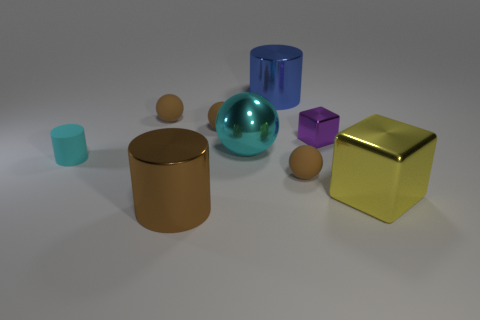There is a small object that is the same color as the metal sphere; what shape is it?
Offer a very short reply. Cylinder. There is a yellow metal thing that is the same shape as the purple thing; what size is it?
Ensure brevity in your answer.  Large. There is a purple thing; is it the same size as the sphere on the right side of the large cyan shiny ball?
Provide a succinct answer. Yes. What is the shape of the tiny matte object in front of the small matte cylinder?
Your answer should be compact. Sphere. There is a big metal cylinder that is behind the tiny ball that is in front of the small cylinder; what is its color?
Offer a very short reply. Blue. There is a tiny rubber thing that is the same shape as the large brown metal object; what is its color?
Your answer should be very brief. Cyan. How many shiny cylinders have the same color as the matte cylinder?
Provide a short and direct response. 0. There is a big metal ball; does it have the same color as the matte cylinder in front of the metallic sphere?
Your answer should be compact. Yes. There is a big object that is both on the right side of the large sphere and behind the yellow metallic thing; what shape is it?
Keep it short and to the point. Cylinder. What material is the brown sphere in front of the thing to the left of the tiny brown matte thing that is on the left side of the large brown shiny cylinder?
Provide a succinct answer. Rubber. 